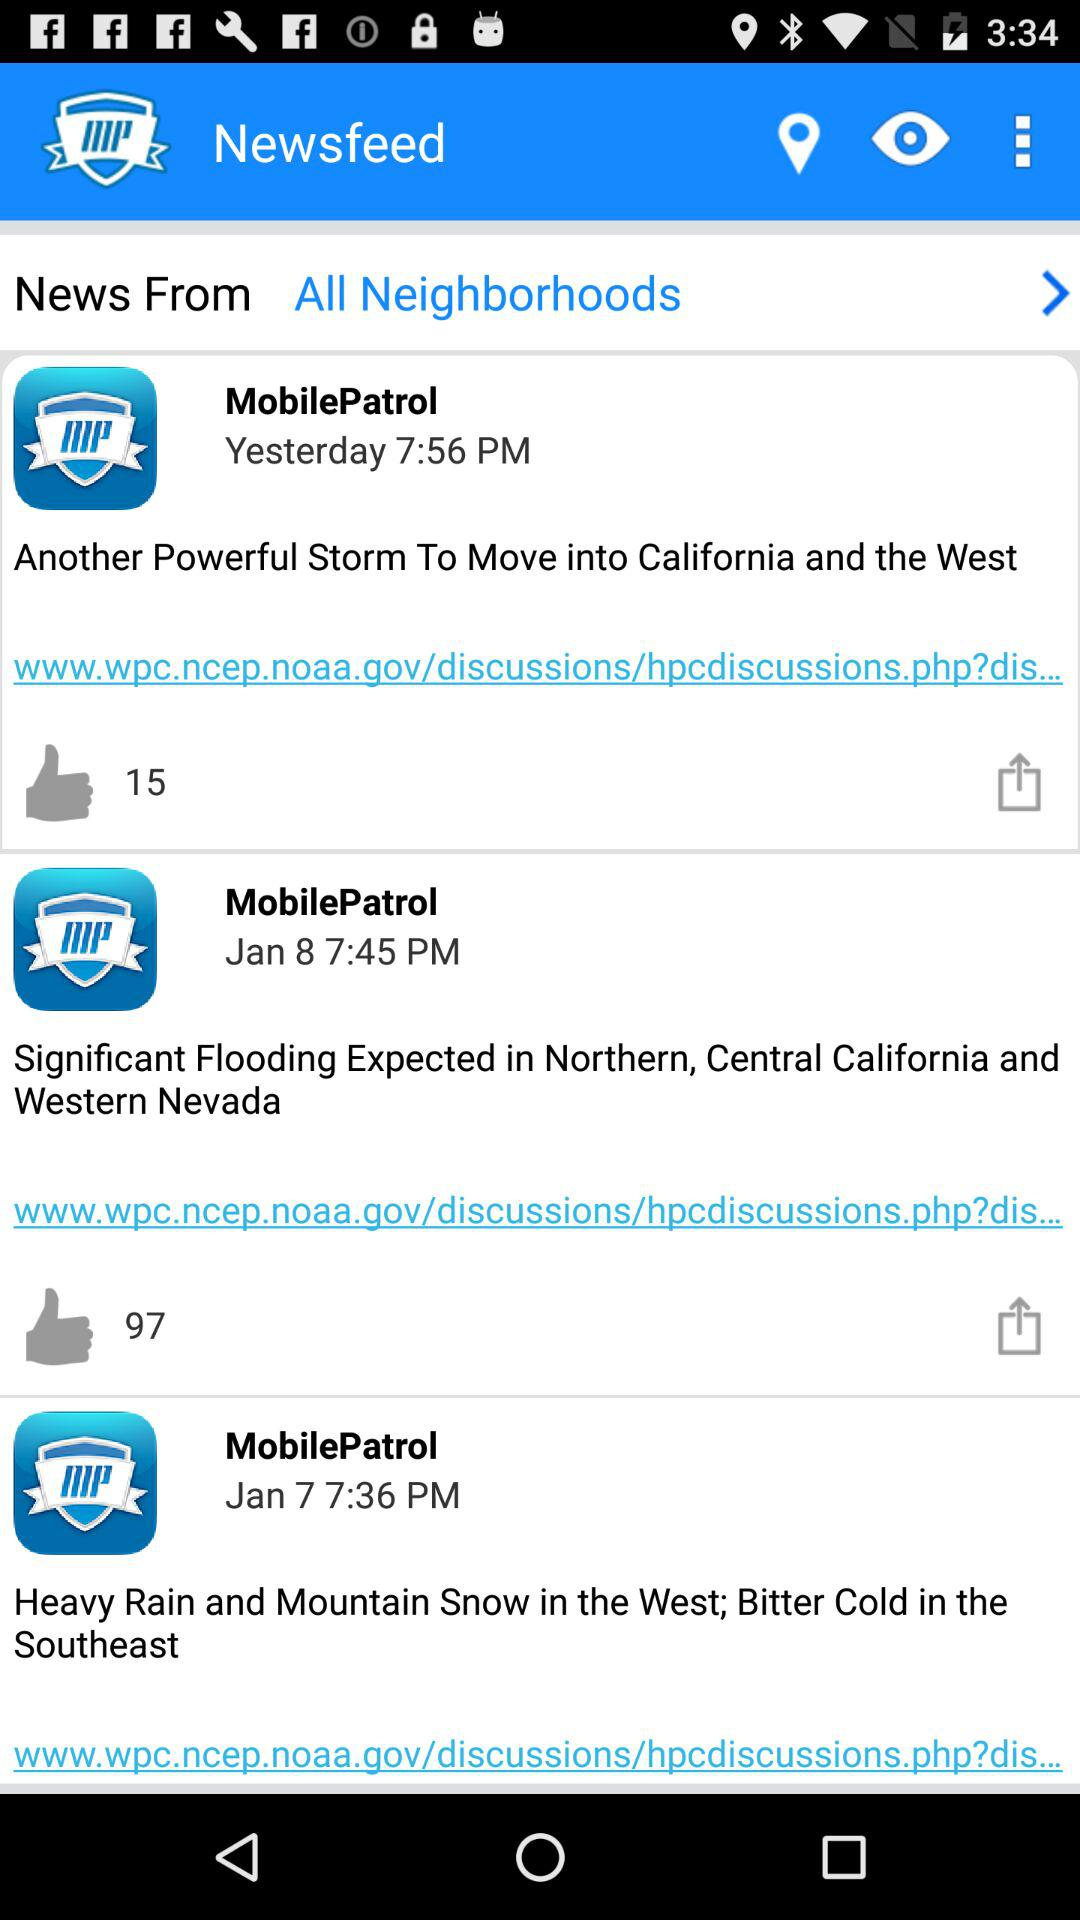How many items are in the news feed?
Answer the question using a single word or phrase. 3 